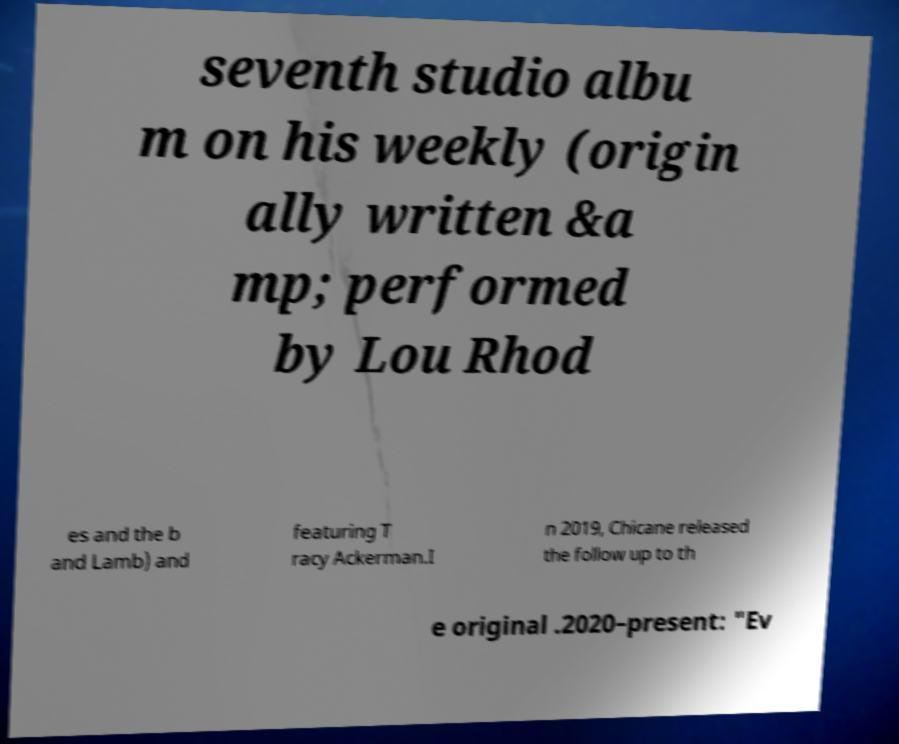What messages or text are displayed in this image? I need them in a readable, typed format. seventh studio albu m on his weekly (origin ally written &a mp; performed by Lou Rhod es and the b and Lamb) and featuring T racy Ackerman.I n 2019, Chicane released the follow up to th e original .2020–present: "Ev 